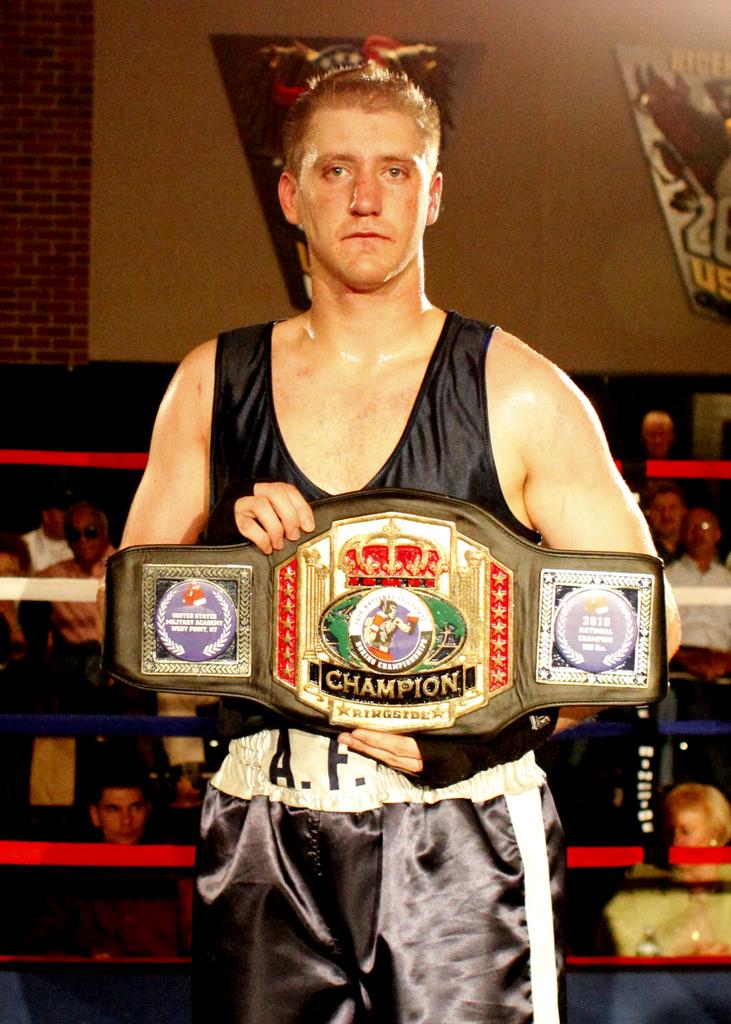What two letters can be seen on the mans shorts?
Offer a very short reply. Af. 